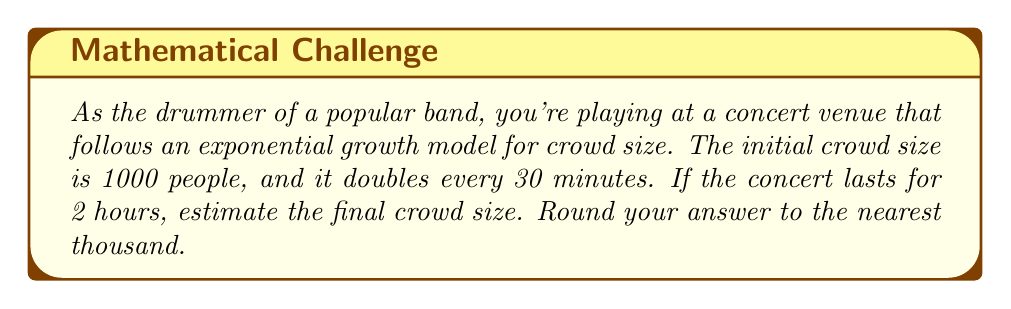Provide a solution to this math problem. Let's approach this step-by-step:

1) We're dealing with an exponential growth function. The general form is:

   $$A(t) = A_0 \cdot b^t$$

   Where:
   $A(t)$ is the amount after time $t$
   $A_0$ is the initial amount
   $b$ is the growth factor
   $t$ is the number of time periods

2) We know:
   - Initial crowd size $A_0 = 1000$
   - The crowd doubles every 30 minutes, so $b = 2$
   - The concert lasts 2 hours = 120 minutes

3) We need to determine how many 30-minute periods are in 2 hours:
   $$t = \frac{120 \text{ minutes}}{30 \text{ minutes/period}} = 4 \text{ periods}$$

4) Now we can plug these values into our exponential growth formula:

   $$A(4) = 1000 \cdot 2^4$$

5) Calculate:
   $$A(4) = 1000 \cdot 16 = 16,000$$

6) Rounding to the nearest thousand:
   16,000 rounds to 16,000
Answer: 16,000 people 